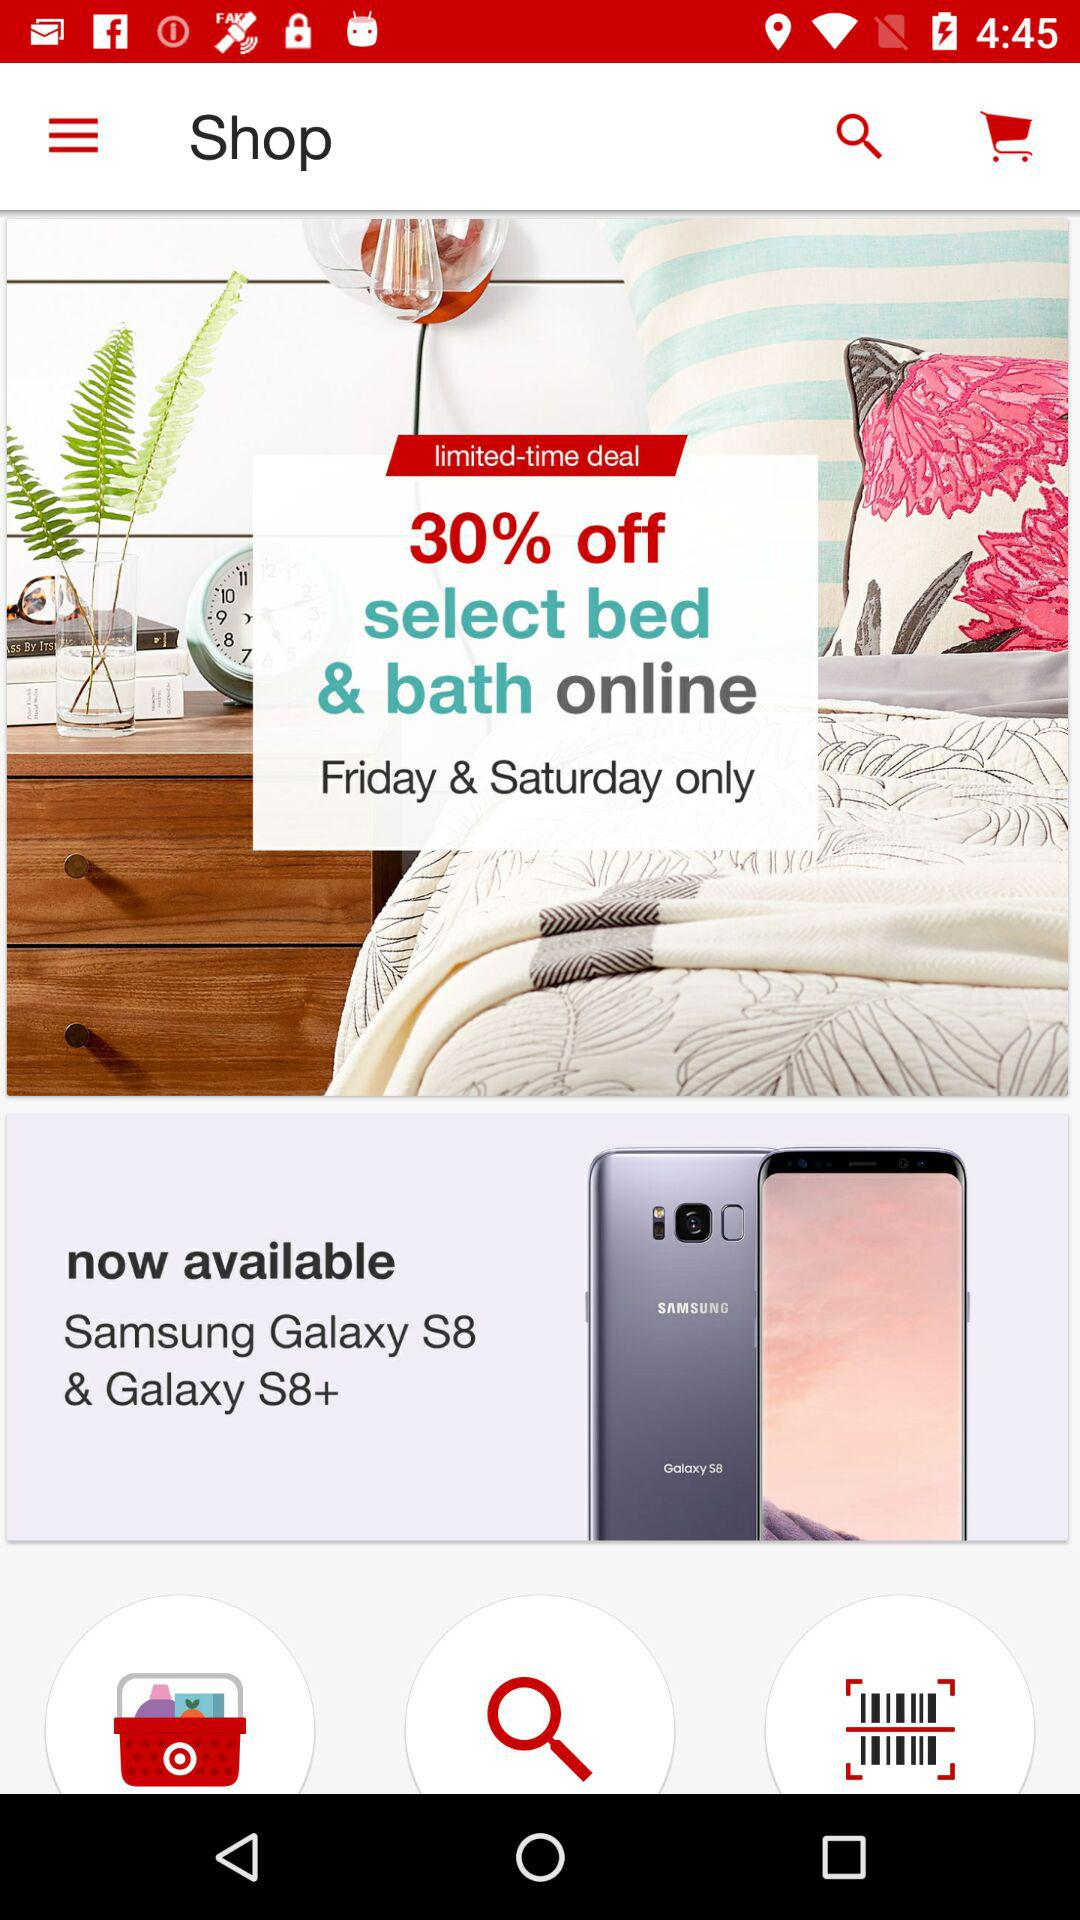On which days is the discount available? The discount is available on Friday and Saturday. 